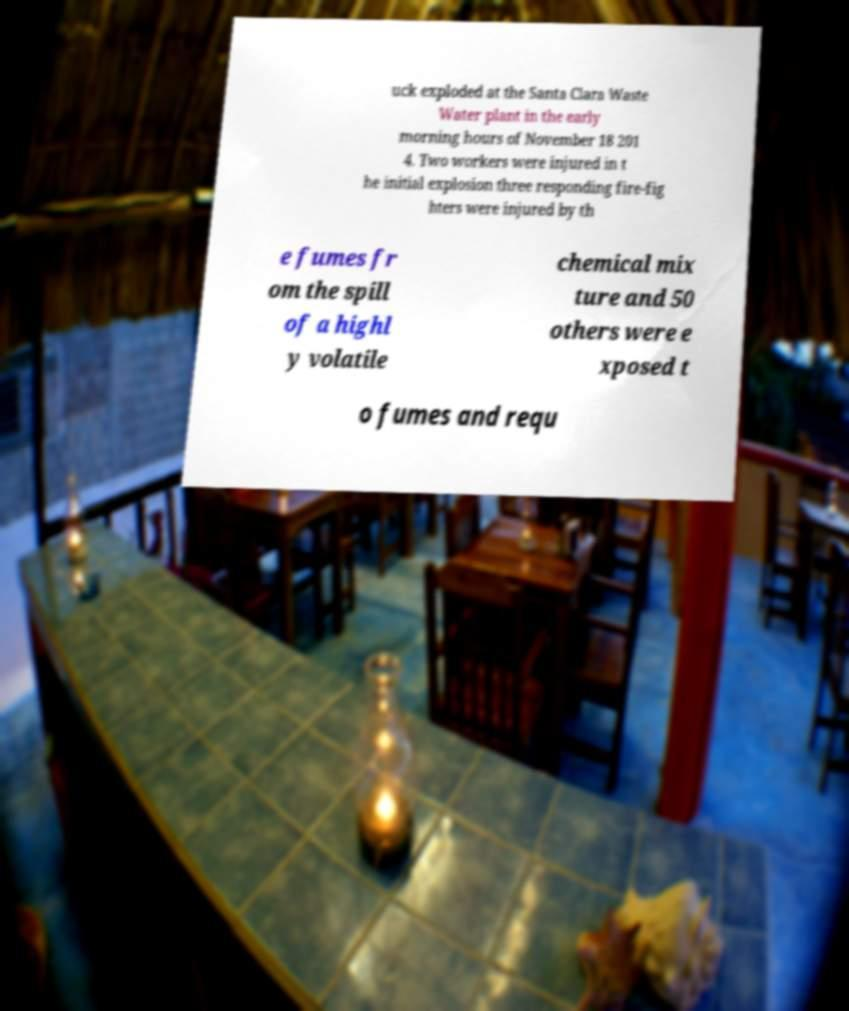I need the written content from this picture converted into text. Can you do that? uck exploded at the Santa Clara Waste Water plant in the early morning hours of November 18 201 4. Two workers were injured in t he initial explosion three responding fire-fig hters were injured by th e fumes fr om the spill of a highl y volatile chemical mix ture and 50 others were e xposed t o fumes and requ 